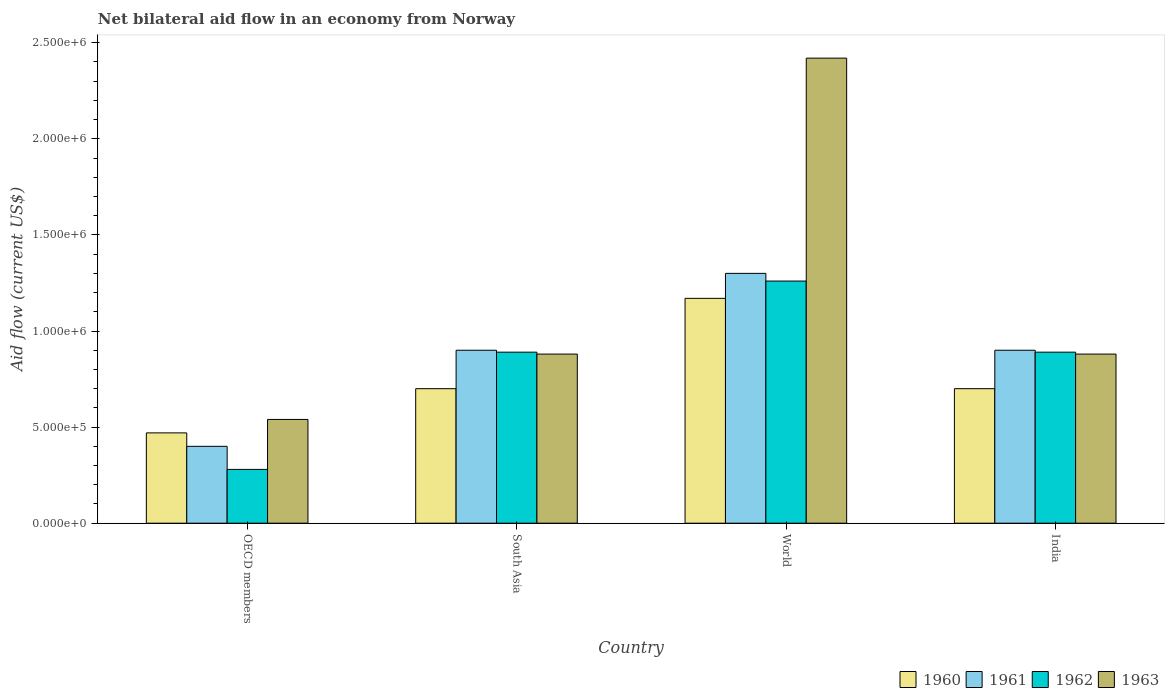How many different coloured bars are there?
Your response must be concise. 4. How many groups of bars are there?
Make the answer very short. 4. Are the number of bars per tick equal to the number of legend labels?
Your response must be concise. Yes. Are the number of bars on each tick of the X-axis equal?
Give a very brief answer. Yes. How many bars are there on the 2nd tick from the right?
Ensure brevity in your answer.  4. Across all countries, what is the maximum net bilateral aid flow in 1962?
Your answer should be very brief. 1.26e+06. In which country was the net bilateral aid flow in 1960 maximum?
Your response must be concise. World. What is the total net bilateral aid flow in 1960 in the graph?
Offer a very short reply. 3.04e+06. What is the difference between the net bilateral aid flow in 1963 in India and that in OECD members?
Your response must be concise. 3.40e+05. What is the difference between the net bilateral aid flow in 1961 in India and the net bilateral aid flow in 1963 in South Asia?
Your response must be concise. 2.00e+04. What is the average net bilateral aid flow in 1962 per country?
Provide a succinct answer. 8.30e+05. In how many countries, is the net bilateral aid flow in 1960 greater than 1100000 US$?
Your response must be concise. 1. What is the ratio of the net bilateral aid flow in 1963 in South Asia to that in World?
Keep it short and to the point. 0.36. Is the net bilateral aid flow in 1961 in OECD members less than that in World?
Offer a very short reply. Yes. What is the difference between the highest and the lowest net bilateral aid flow in 1961?
Provide a short and direct response. 9.00e+05. In how many countries, is the net bilateral aid flow in 1960 greater than the average net bilateral aid flow in 1960 taken over all countries?
Offer a terse response. 1. How many bars are there?
Your response must be concise. 16. Are all the bars in the graph horizontal?
Provide a succinct answer. No. How many legend labels are there?
Your answer should be compact. 4. What is the title of the graph?
Your response must be concise. Net bilateral aid flow in an economy from Norway. What is the Aid flow (current US$) in 1960 in OECD members?
Your response must be concise. 4.70e+05. What is the Aid flow (current US$) in 1962 in OECD members?
Make the answer very short. 2.80e+05. What is the Aid flow (current US$) in 1963 in OECD members?
Your answer should be compact. 5.40e+05. What is the Aid flow (current US$) of 1961 in South Asia?
Ensure brevity in your answer.  9.00e+05. What is the Aid flow (current US$) in 1962 in South Asia?
Make the answer very short. 8.90e+05. What is the Aid flow (current US$) in 1963 in South Asia?
Give a very brief answer. 8.80e+05. What is the Aid flow (current US$) in 1960 in World?
Offer a terse response. 1.17e+06. What is the Aid flow (current US$) in 1961 in World?
Provide a succinct answer. 1.30e+06. What is the Aid flow (current US$) in 1962 in World?
Offer a terse response. 1.26e+06. What is the Aid flow (current US$) in 1963 in World?
Your response must be concise. 2.42e+06. What is the Aid flow (current US$) of 1961 in India?
Provide a short and direct response. 9.00e+05. What is the Aid flow (current US$) in 1962 in India?
Your response must be concise. 8.90e+05. What is the Aid flow (current US$) in 1963 in India?
Your answer should be compact. 8.80e+05. Across all countries, what is the maximum Aid flow (current US$) in 1960?
Ensure brevity in your answer.  1.17e+06. Across all countries, what is the maximum Aid flow (current US$) in 1961?
Your answer should be compact. 1.30e+06. Across all countries, what is the maximum Aid flow (current US$) in 1962?
Make the answer very short. 1.26e+06. Across all countries, what is the maximum Aid flow (current US$) in 1963?
Offer a very short reply. 2.42e+06. Across all countries, what is the minimum Aid flow (current US$) of 1963?
Provide a short and direct response. 5.40e+05. What is the total Aid flow (current US$) in 1960 in the graph?
Keep it short and to the point. 3.04e+06. What is the total Aid flow (current US$) in 1961 in the graph?
Offer a very short reply. 3.50e+06. What is the total Aid flow (current US$) of 1962 in the graph?
Your response must be concise. 3.32e+06. What is the total Aid flow (current US$) in 1963 in the graph?
Provide a succinct answer. 4.72e+06. What is the difference between the Aid flow (current US$) of 1960 in OECD members and that in South Asia?
Your answer should be compact. -2.30e+05. What is the difference between the Aid flow (current US$) of 1961 in OECD members and that in South Asia?
Provide a succinct answer. -5.00e+05. What is the difference between the Aid flow (current US$) of 1962 in OECD members and that in South Asia?
Ensure brevity in your answer.  -6.10e+05. What is the difference between the Aid flow (current US$) of 1963 in OECD members and that in South Asia?
Ensure brevity in your answer.  -3.40e+05. What is the difference between the Aid flow (current US$) in 1960 in OECD members and that in World?
Your answer should be compact. -7.00e+05. What is the difference between the Aid flow (current US$) in 1961 in OECD members and that in World?
Give a very brief answer. -9.00e+05. What is the difference between the Aid flow (current US$) of 1962 in OECD members and that in World?
Give a very brief answer. -9.80e+05. What is the difference between the Aid flow (current US$) in 1963 in OECD members and that in World?
Your response must be concise. -1.88e+06. What is the difference between the Aid flow (current US$) in 1961 in OECD members and that in India?
Make the answer very short. -5.00e+05. What is the difference between the Aid flow (current US$) in 1962 in OECD members and that in India?
Keep it short and to the point. -6.10e+05. What is the difference between the Aid flow (current US$) of 1960 in South Asia and that in World?
Offer a very short reply. -4.70e+05. What is the difference between the Aid flow (current US$) in 1961 in South Asia and that in World?
Your answer should be compact. -4.00e+05. What is the difference between the Aid flow (current US$) of 1962 in South Asia and that in World?
Offer a very short reply. -3.70e+05. What is the difference between the Aid flow (current US$) in 1963 in South Asia and that in World?
Ensure brevity in your answer.  -1.54e+06. What is the difference between the Aid flow (current US$) of 1961 in South Asia and that in India?
Provide a short and direct response. 0. What is the difference between the Aid flow (current US$) of 1962 in South Asia and that in India?
Give a very brief answer. 0. What is the difference between the Aid flow (current US$) of 1960 in World and that in India?
Provide a succinct answer. 4.70e+05. What is the difference between the Aid flow (current US$) in 1961 in World and that in India?
Offer a very short reply. 4.00e+05. What is the difference between the Aid flow (current US$) of 1962 in World and that in India?
Offer a very short reply. 3.70e+05. What is the difference between the Aid flow (current US$) of 1963 in World and that in India?
Offer a very short reply. 1.54e+06. What is the difference between the Aid flow (current US$) in 1960 in OECD members and the Aid flow (current US$) in 1961 in South Asia?
Give a very brief answer. -4.30e+05. What is the difference between the Aid flow (current US$) of 1960 in OECD members and the Aid flow (current US$) of 1962 in South Asia?
Your answer should be very brief. -4.20e+05. What is the difference between the Aid flow (current US$) in 1960 in OECD members and the Aid flow (current US$) in 1963 in South Asia?
Give a very brief answer. -4.10e+05. What is the difference between the Aid flow (current US$) in 1961 in OECD members and the Aid flow (current US$) in 1962 in South Asia?
Your response must be concise. -4.90e+05. What is the difference between the Aid flow (current US$) in 1961 in OECD members and the Aid flow (current US$) in 1963 in South Asia?
Make the answer very short. -4.80e+05. What is the difference between the Aid flow (current US$) in 1962 in OECD members and the Aid flow (current US$) in 1963 in South Asia?
Make the answer very short. -6.00e+05. What is the difference between the Aid flow (current US$) of 1960 in OECD members and the Aid flow (current US$) of 1961 in World?
Keep it short and to the point. -8.30e+05. What is the difference between the Aid flow (current US$) of 1960 in OECD members and the Aid flow (current US$) of 1962 in World?
Ensure brevity in your answer.  -7.90e+05. What is the difference between the Aid flow (current US$) in 1960 in OECD members and the Aid flow (current US$) in 1963 in World?
Keep it short and to the point. -1.95e+06. What is the difference between the Aid flow (current US$) in 1961 in OECD members and the Aid flow (current US$) in 1962 in World?
Make the answer very short. -8.60e+05. What is the difference between the Aid flow (current US$) in 1961 in OECD members and the Aid flow (current US$) in 1963 in World?
Offer a very short reply. -2.02e+06. What is the difference between the Aid flow (current US$) in 1962 in OECD members and the Aid flow (current US$) in 1963 in World?
Your answer should be very brief. -2.14e+06. What is the difference between the Aid flow (current US$) of 1960 in OECD members and the Aid flow (current US$) of 1961 in India?
Give a very brief answer. -4.30e+05. What is the difference between the Aid flow (current US$) in 1960 in OECD members and the Aid flow (current US$) in 1962 in India?
Ensure brevity in your answer.  -4.20e+05. What is the difference between the Aid flow (current US$) in 1960 in OECD members and the Aid flow (current US$) in 1963 in India?
Ensure brevity in your answer.  -4.10e+05. What is the difference between the Aid flow (current US$) in 1961 in OECD members and the Aid flow (current US$) in 1962 in India?
Your answer should be very brief. -4.90e+05. What is the difference between the Aid flow (current US$) of 1961 in OECD members and the Aid flow (current US$) of 1963 in India?
Your answer should be compact. -4.80e+05. What is the difference between the Aid flow (current US$) in 1962 in OECD members and the Aid flow (current US$) in 1963 in India?
Make the answer very short. -6.00e+05. What is the difference between the Aid flow (current US$) of 1960 in South Asia and the Aid flow (current US$) of 1961 in World?
Provide a short and direct response. -6.00e+05. What is the difference between the Aid flow (current US$) of 1960 in South Asia and the Aid flow (current US$) of 1962 in World?
Your answer should be compact. -5.60e+05. What is the difference between the Aid flow (current US$) of 1960 in South Asia and the Aid flow (current US$) of 1963 in World?
Offer a very short reply. -1.72e+06. What is the difference between the Aid flow (current US$) in 1961 in South Asia and the Aid flow (current US$) in 1962 in World?
Your response must be concise. -3.60e+05. What is the difference between the Aid flow (current US$) of 1961 in South Asia and the Aid flow (current US$) of 1963 in World?
Give a very brief answer. -1.52e+06. What is the difference between the Aid flow (current US$) of 1962 in South Asia and the Aid flow (current US$) of 1963 in World?
Keep it short and to the point. -1.53e+06. What is the difference between the Aid flow (current US$) of 1961 in South Asia and the Aid flow (current US$) of 1962 in India?
Ensure brevity in your answer.  10000. What is the difference between the Aid flow (current US$) of 1961 in South Asia and the Aid flow (current US$) of 1963 in India?
Your answer should be very brief. 2.00e+04. What is the difference between the Aid flow (current US$) in 1962 in South Asia and the Aid flow (current US$) in 1963 in India?
Provide a short and direct response. 10000. What is the difference between the Aid flow (current US$) of 1960 in World and the Aid flow (current US$) of 1961 in India?
Make the answer very short. 2.70e+05. What is the difference between the Aid flow (current US$) of 1961 in World and the Aid flow (current US$) of 1963 in India?
Ensure brevity in your answer.  4.20e+05. What is the difference between the Aid flow (current US$) of 1962 in World and the Aid flow (current US$) of 1963 in India?
Your answer should be very brief. 3.80e+05. What is the average Aid flow (current US$) of 1960 per country?
Make the answer very short. 7.60e+05. What is the average Aid flow (current US$) in 1961 per country?
Provide a succinct answer. 8.75e+05. What is the average Aid flow (current US$) of 1962 per country?
Your response must be concise. 8.30e+05. What is the average Aid flow (current US$) in 1963 per country?
Offer a very short reply. 1.18e+06. What is the difference between the Aid flow (current US$) in 1960 and Aid flow (current US$) in 1961 in OECD members?
Offer a very short reply. 7.00e+04. What is the difference between the Aid flow (current US$) in 1960 and Aid flow (current US$) in 1962 in OECD members?
Your answer should be very brief. 1.90e+05. What is the difference between the Aid flow (current US$) in 1961 and Aid flow (current US$) in 1962 in OECD members?
Offer a terse response. 1.20e+05. What is the difference between the Aid flow (current US$) of 1961 and Aid flow (current US$) of 1963 in OECD members?
Your answer should be compact. -1.40e+05. What is the difference between the Aid flow (current US$) in 1962 and Aid flow (current US$) in 1963 in OECD members?
Offer a terse response. -2.60e+05. What is the difference between the Aid flow (current US$) in 1960 and Aid flow (current US$) in 1961 in South Asia?
Your answer should be very brief. -2.00e+05. What is the difference between the Aid flow (current US$) of 1960 and Aid flow (current US$) of 1963 in South Asia?
Offer a terse response. -1.80e+05. What is the difference between the Aid flow (current US$) of 1961 and Aid flow (current US$) of 1962 in South Asia?
Your response must be concise. 10000. What is the difference between the Aid flow (current US$) in 1962 and Aid flow (current US$) in 1963 in South Asia?
Your answer should be very brief. 10000. What is the difference between the Aid flow (current US$) of 1960 and Aid flow (current US$) of 1962 in World?
Offer a very short reply. -9.00e+04. What is the difference between the Aid flow (current US$) in 1960 and Aid flow (current US$) in 1963 in World?
Your response must be concise. -1.25e+06. What is the difference between the Aid flow (current US$) in 1961 and Aid flow (current US$) in 1963 in World?
Ensure brevity in your answer.  -1.12e+06. What is the difference between the Aid flow (current US$) of 1962 and Aid flow (current US$) of 1963 in World?
Offer a very short reply. -1.16e+06. What is the difference between the Aid flow (current US$) of 1960 and Aid flow (current US$) of 1962 in India?
Provide a succinct answer. -1.90e+05. What is the ratio of the Aid flow (current US$) of 1960 in OECD members to that in South Asia?
Make the answer very short. 0.67. What is the ratio of the Aid flow (current US$) in 1961 in OECD members to that in South Asia?
Keep it short and to the point. 0.44. What is the ratio of the Aid flow (current US$) in 1962 in OECD members to that in South Asia?
Your answer should be very brief. 0.31. What is the ratio of the Aid flow (current US$) in 1963 in OECD members to that in South Asia?
Your answer should be very brief. 0.61. What is the ratio of the Aid flow (current US$) of 1960 in OECD members to that in World?
Your answer should be compact. 0.4. What is the ratio of the Aid flow (current US$) in 1961 in OECD members to that in World?
Ensure brevity in your answer.  0.31. What is the ratio of the Aid flow (current US$) in 1962 in OECD members to that in World?
Make the answer very short. 0.22. What is the ratio of the Aid flow (current US$) in 1963 in OECD members to that in World?
Offer a terse response. 0.22. What is the ratio of the Aid flow (current US$) in 1960 in OECD members to that in India?
Provide a short and direct response. 0.67. What is the ratio of the Aid flow (current US$) of 1961 in OECD members to that in India?
Ensure brevity in your answer.  0.44. What is the ratio of the Aid flow (current US$) in 1962 in OECD members to that in India?
Offer a terse response. 0.31. What is the ratio of the Aid flow (current US$) of 1963 in OECD members to that in India?
Give a very brief answer. 0.61. What is the ratio of the Aid flow (current US$) of 1960 in South Asia to that in World?
Give a very brief answer. 0.6. What is the ratio of the Aid flow (current US$) of 1961 in South Asia to that in World?
Provide a short and direct response. 0.69. What is the ratio of the Aid flow (current US$) of 1962 in South Asia to that in World?
Provide a short and direct response. 0.71. What is the ratio of the Aid flow (current US$) in 1963 in South Asia to that in World?
Make the answer very short. 0.36. What is the ratio of the Aid flow (current US$) in 1961 in South Asia to that in India?
Your response must be concise. 1. What is the ratio of the Aid flow (current US$) in 1963 in South Asia to that in India?
Keep it short and to the point. 1. What is the ratio of the Aid flow (current US$) in 1960 in World to that in India?
Offer a terse response. 1.67. What is the ratio of the Aid flow (current US$) in 1961 in World to that in India?
Offer a terse response. 1.44. What is the ratio of the Aid flow (current US$) of 1962 in World to that in India?
Offer a terse response. 1.42. What is the ratio of the Aid flow (current US$) of 1963 in World to that in India?
Keep it short and to the point. 2.75. What is the difference between the highest and the second highest Aid flow (current US$) in 1960?
Provide a short and direct response. 4.70e+05. What is the difference between the highest and the second highest Aid flow (current US$) of 1963?
Give a very brief answer. 1.54e+06. What is the difference between the highest and the lowest Aid flow (current US$) in 1961?
Your answer should be compact. 9.00e+05. What is the difference between the highest and the lowest Aid flow (current US$) in 1962?
Offer a very short reply. 9.80e+05. What is the difference between the highest and the lowest Aid flow (current US$) of 1963?
Your answer should be very brief. 1.88e+06. 